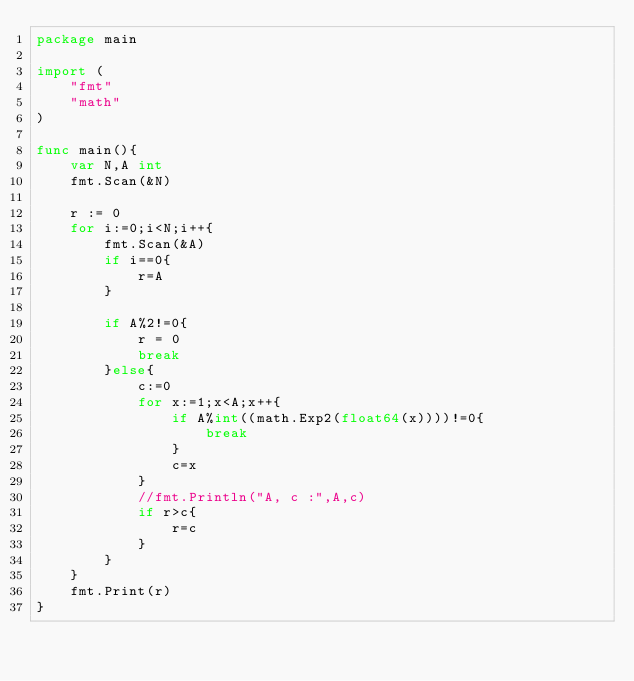<code> <loc_0><loc_0><loc_500><loc_500><_Go_>package main

import (
	"fmt"
	"math"
)

func main(){
	var N,A int
	fmt.Scan(&N)

	r := 0
	for i:=0;i<N;i++{
		fmt.Scan(&A)
		if i==0{
			r=A
		}

		if A%2!=0{
			r = 0
			break
		}else{
			c:=0
			for x:=1;x<A;x++{
				if A%int((math.Exp2(float64(x))))!=0{
					break
				}
				c=x
			}
			//fmt.Println("A, c :",A,c)
			if r>c{
				r=c
			}
		}
	}
	fmt.Print(r)
}</code> 